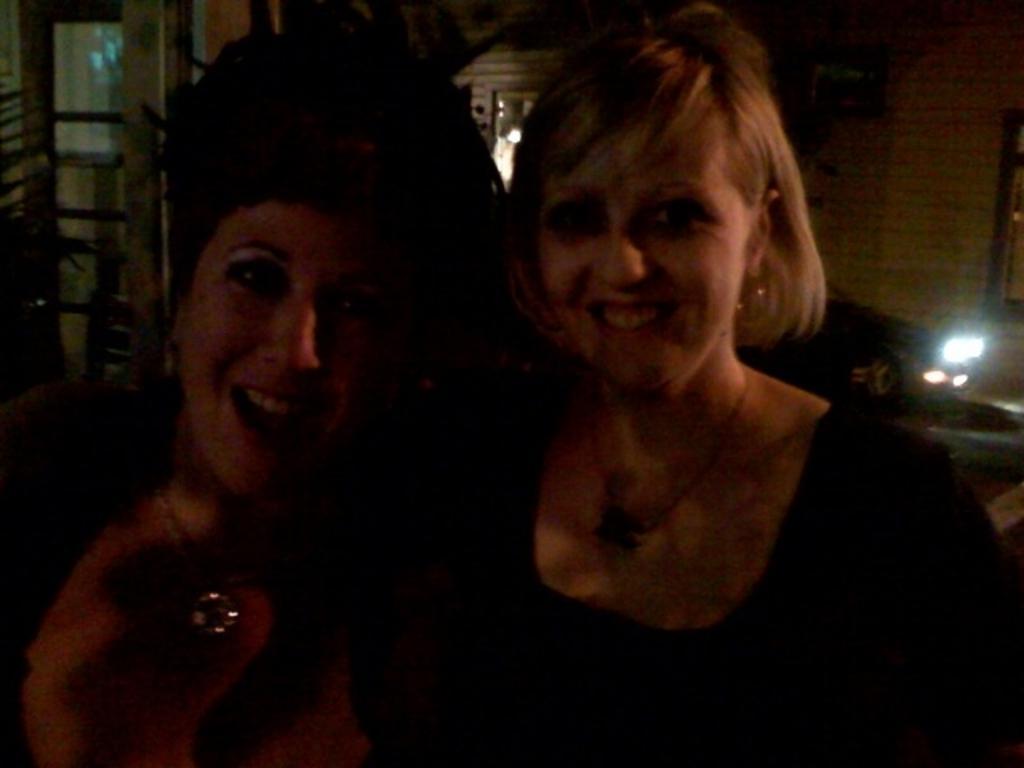How would you summarize this image in a sentence or two? In this image I can see two people are smiling. I can see the light, plants and few objects around. 